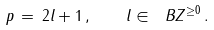Convert formula to latex. <formula><loc_0><loc_0><loc_500><loc_500>p \, = \, 2 l + 1 \, , \quad l \in \ B Z ^ { \geq 0 } \, .</formula> 